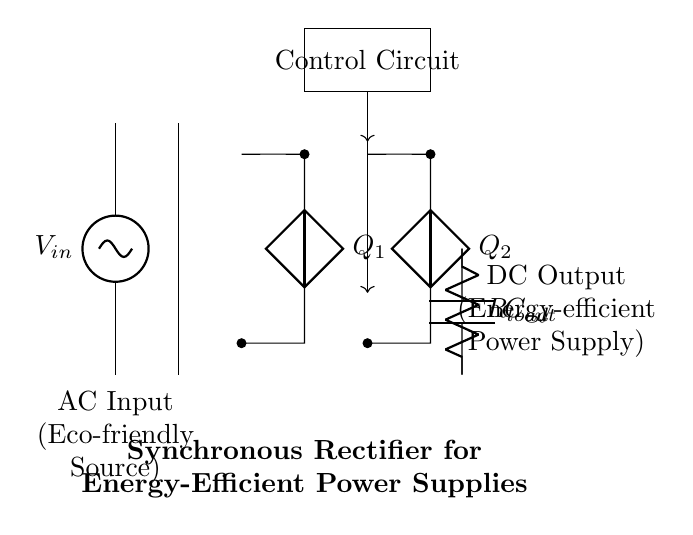What is the input type of this circuit? The circuit receives alternating current, indicated by the symbol for AC input at the beginning of the diagram.
Answer: Alternating Current (AC) What are the two primary components of the rectifier? The primary components are switches, represented by Q1 and Q2. These components are necessary for converting AC to DC by allowing current to pass through in only one direction.
Answer: Q1 and Q2 What is the purpose of the control circuit? The control circuit manages the operation of the switches, optimizing the rectification process to enhance efficiency.
Answer: Manage switches What does the output load consist of? The output load includes a capacitor and a resistor, which store and dissipate energy, respectively. This indicates the circuit is providing power to a load.
Answer: Capacitor and Resistor How does this rectifier enhance energy efficiency? The synchronous rectifier minimizes voltage drop compared to traditional diode rectifiers by using active components to conduct current, resulting in reduced energy losses.
Answer: Active components What does DC output signify in this context? The DC output indicates that the circuit has successfully converted the AC input into direct current suitable for modern electronic devices.
Answer: Direct Current (DC) What type of transformer is illustrated in the circuit? The image shows a transformer core, which is a crucial part of stepping down the voltage from the input AC to usable levels for the rectifier.
Answer: Transformer Core 